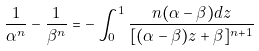Convert formula to latex. <formula><loc_0><loc_0><loc_500><loc_500>\frac { 1 } { \alpha ^ { n } } - \frac { 1 } { \beta ^ { n } } = - \int ^ { 1 } _ { 0 } \frac { n ( \alpha - \beta ) d z } { [ ( \alpha - \beta ) z + \beta ] ^ { n + 1 } }</formula> 